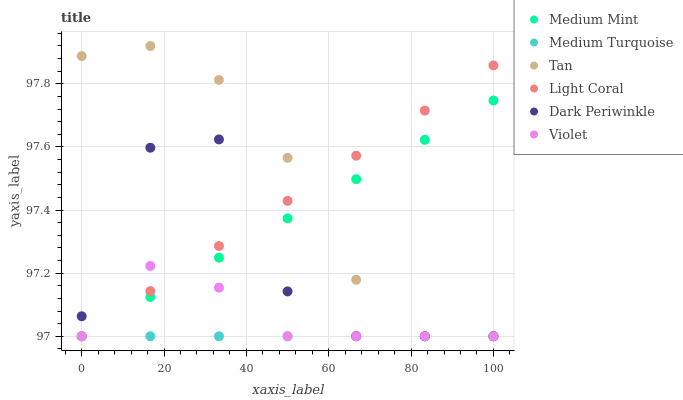Does Medium Turquoise have the minimum area under the curve?
Answer yes or no. Yes. Does Tan have the maximum area under the curve?
Answer yes or no. Yes. Does Light Coral have the minimum area under the curve?
Answer yes or no. No. Does Light Coral have the maximum area under the curve?
Answer yes or no. No. Is Medium Turquoise the smoothest?
Answer yes or no. Yes. Is Dark Periwinkle the roughest?
Answer yes or no. Yes. Is Light Coral the smoothest?
Answer yes or no. No. Is Light Coral the roughest?
Answer yes or no. No. Does Medium Mint have the lowest value?
Answer yes or no. Yes. Does Tan have the highest value?
Answer yes or no. Yes. Does Light Coral have the highest value?
Answer yes or no. No. Does Medium Turquoise intersect Dark Periwinkle?
Answer yes or no. Yes. Is Medium Turquoise less than Dark Periwinkle?
Answer yes or no. No. Is Medium Turquoise greater than Dark Periwinkle?
Answer yes or no. No. 